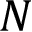<formula> <loc_0><loc_0><loc_500><loc_500>N</formula> 